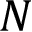<formula> <loc_0><loc_0><loc_500><loc_500>N</formula> 